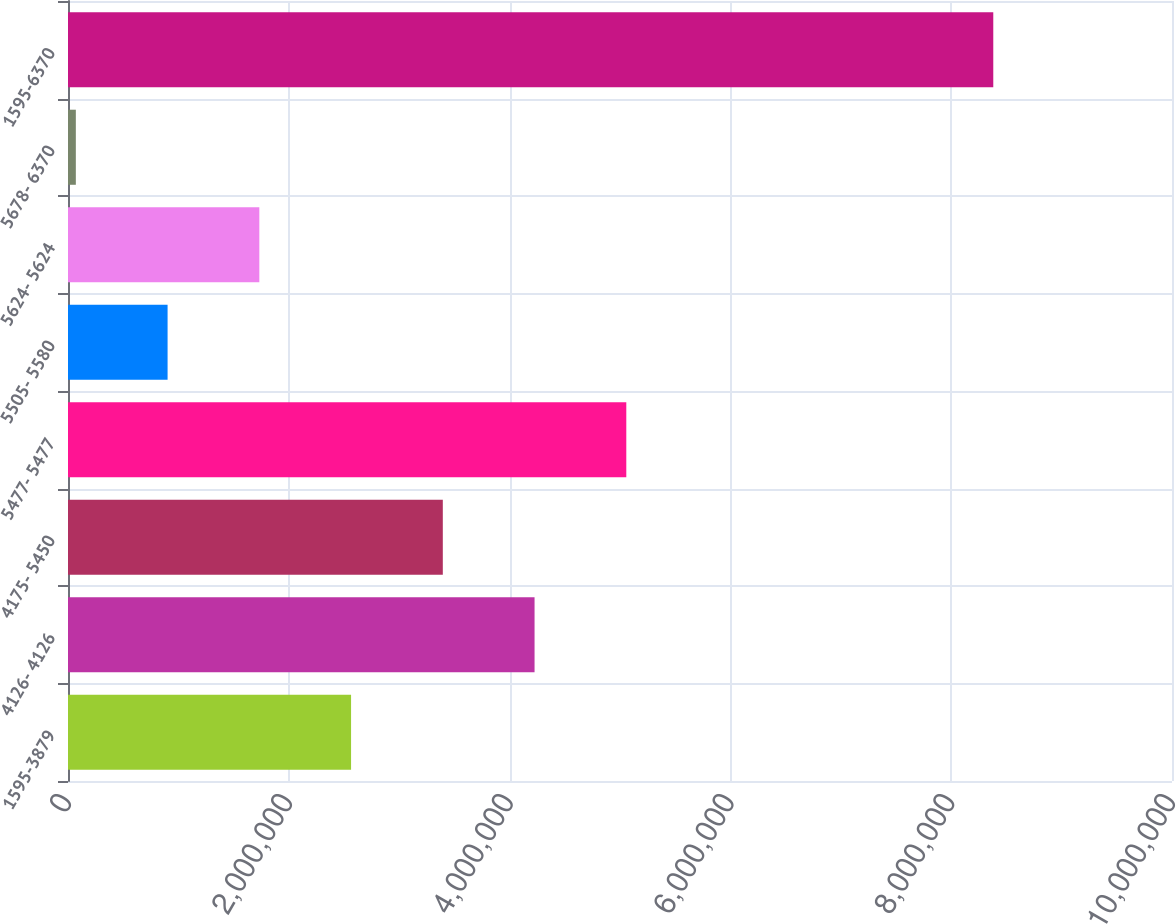Convert chart. <chart><loc_0><loc_0><loc_500><loc_500><bar_chart><fcel>1595-3879<fcel>4126- 4126<fcel>4175- 5450<fcel>5477- 5477<fcel>5505- 5580<fcel>5624- 5624<fcel>5678- 6370<fcel>1595-6370<nl><fcel>2.56404e+06<fcel>4.22606e+06<fcel>3.39505e+06<fcel>5.05707e+06<fcel>902012<fcel>1.73302e+06<fcel>71000<fcel>8.38112e+06<nl></chart> 